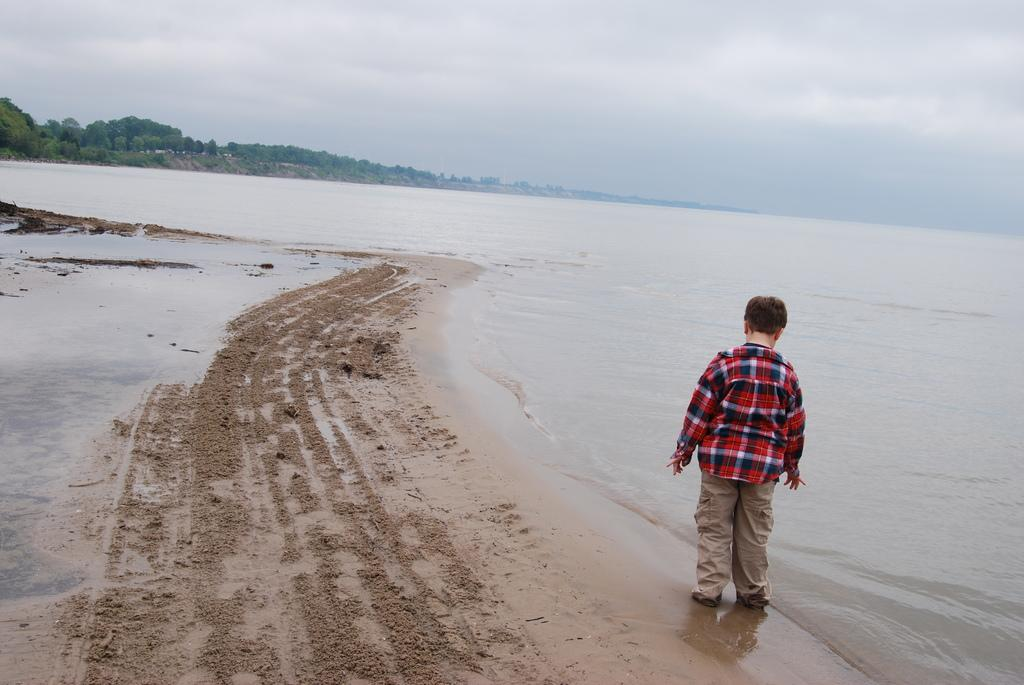What is the main subject of the image? There is a person standing in the image. What can be seen in the background of the image? There are trees in the background of the image. What is visible at the bottom of the image? There is water and sand visible at the bottom of the image. What is visible at the top of the image? The sky is visible at the top of the image. Where is the sponge located in the image? There is no sponge present in the image. What color is the spot on the person's shirt in the image? There is no spot visible on the person's shirt in the image. 